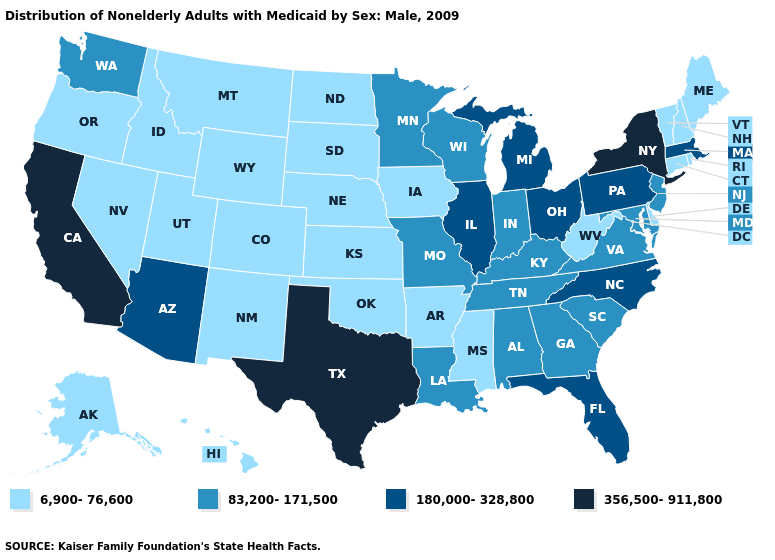What is the value of Nebraska?
Concise answer only. 6,900-76,600. Name the states that have a value in the range 83,200-171,500?
Write a very short answer. Alabama, Georgia, Indiana, Kentucky, Louisiana, Maryland, Minnesota, Missouri, New Jersey, South Carolina, Tennessee, Virginia, Washington, Wisconsin. What is the value of Tennessee?
Short answer required. 83,200-171,500. Does the map have missing data?
Write a very short answer. No. What is the value of California?
Answer briefly. 356,500-911,800. Name the states that have a value in the range 6,900-76,600?
Keep it brief. Alaska, Arkansas, Colorado, Connecticut, Delaware, Hawaii, Idaho, Iowa, Kansas, Maine, Mississippi, Montana, Nebraska, Nevada, New Hampshire, New Mexico, North Dakota, Oklahoma, Oregon, Rhode Island, South Dakota, Utah, Vermont, West Virginia, Wyoming. Does Maryland have the lowest value in the USA?
Answer briefly. No. Among the states that border Georgia , which have the lowest value?
Give a very brief answer. Alabama, South Carolina, Tennessee. Name the states that have a value in the range 180,000-328,800?
Be succinct. Arizona, Florida, Illinois, Massachusetts, Michigan, North Carolina, Ohio, Pennsylvania. Which states hav the highest value in the MidWest?
Keep it brief. Illinois, Michigan, Ohio. What is the value of California?
Short answer required. 356,500-911,800. Does New Mexico have the lowest value in the West?
Quick response, please. Yes. Among the states that border Iowa , which have the lowest value?
Short answer required. Nebraska, South Dakota. What is the value of Nevada?
Be succinct. 6,900-76,600. What is the value of Kentucky?
Short answer required. 83,200-171,500. 